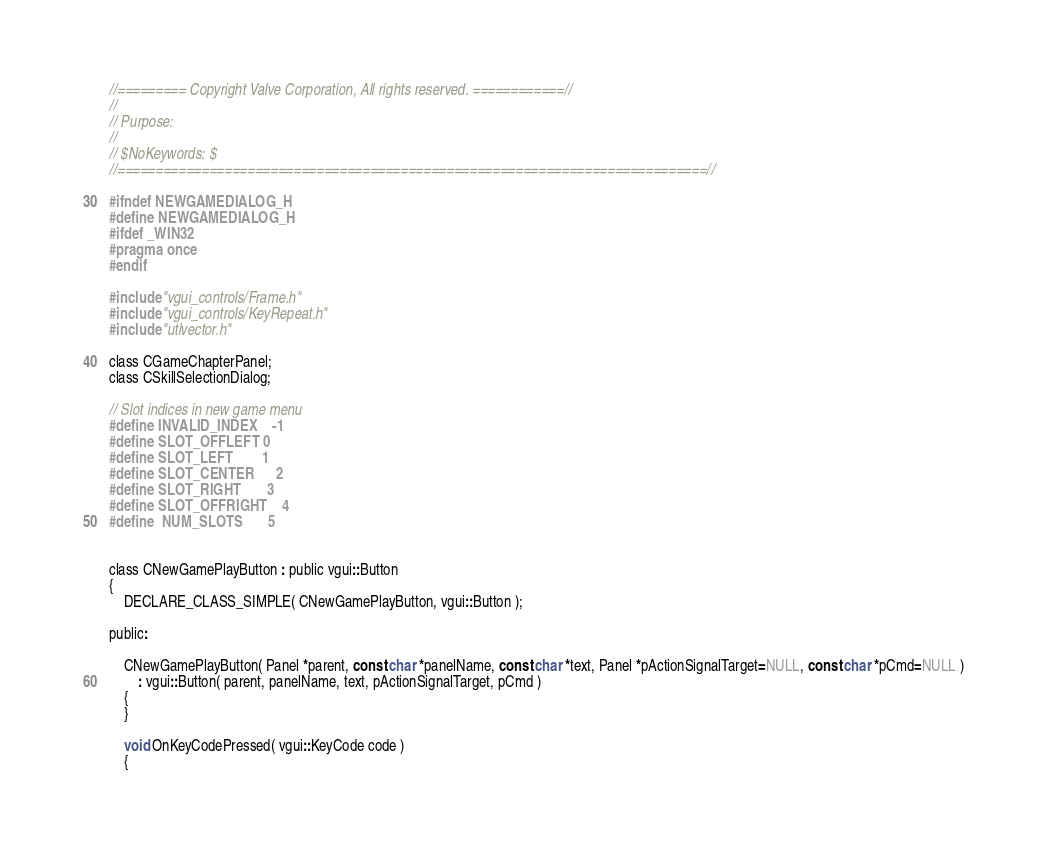<code> <loc_0><loc_0><loc_500><loc_500><_C_>//========= Copyright Valve Corporation, All rights reserved. ============//
//
// Purpose: 
//
// $NoKeywords: $
//=============================================================================//

#ifndef NEWGAMEDIALOG_H
#define NEWGAMEDIALOG_H
#ifdef _WIN32
#pragma once
#endif

#include "vgui_controls/Frame.h"
#include "vgui_controls/KeyRepeat.h"
#include "utlvector.h"

class CGameChapterPanel;
class CSkillSelectionDialog;

// Slot indices in new game menu
#define INVALID_INDEX	-1
#define SLOT_OFFLEFT	0
#define SLOT_LEFT		1
#define SLOT_CENTER		2
#define SLOT_RIGHT		3
#define SLOT_OFFRIGHT	4
#define	NUM_SLOTS		5


class CNewGamePlayButton : public vgui::Button
{
	DECLARE_CLASS_SIMPLE( CNewGamePlayButton, vgui::Button );

public:

	CNewGamePlayButton( Panel *parent, const char *panelName, const char *text, Panel *pActionSignalTarget=NULL, const char *pCmd=NULL )
		: vgui::Button( parent, panelName, text, pActionSignalTarget, pCmd )
	{
	}

	void OnKeyCodePressed( vgui::KeyCode code )
	{</code> 